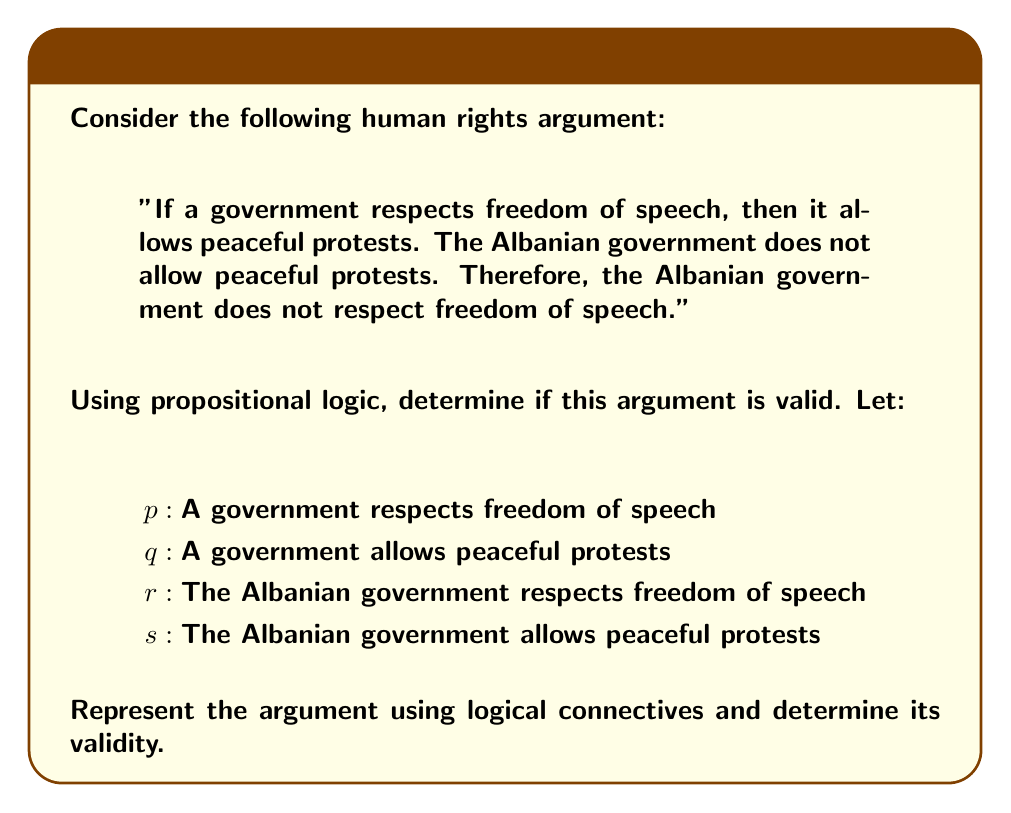What is the answer to this math problem? To analyze this argument using propositional logic, we'll follow these steps:

1) First, let's represent the given statements using logical connectives:

   Premise 1: $p \rightarrow q$ (If a government respects freedom of speech, then it allows peaceful protests)
   Premise 2: $\neg s$ (The Albanian government does not allow peaceful protests)
   Conclusion: $\neg r$ (The Albanian government does not respect freedom of speech)

2) The structure of this argument is:

   $$(p \rightarrow q) \land \neg s \therefore \neg r$$

3) To determine if this argument is valid, we need to check if the conclusion logically follows from the premises. In this case, we're using a form of argument known as modus tollens.

4) The general form of modus tollens is:

   $$p \rightarrow q$$
   $$\neg q$$
   $$\therefore \neg p$$

5) However, our argument doesn't exactly match this form. We have $\neg s$ instead of $\neg q$, and $\neg r$ instead of $\neg p$.

6) For this argument to be valid, we need to establish that $s$ is equivalent to $q$, and $r$ is equivalent to $p$, but for the specific case of the Albanian government.

7) If we accept these equivalences (which are implied by the context of the argument), then the argument does indeed follow the form of modus tollens and is therefore valid.

8) However, it's important to note that the validity of the argument doesn't guarantee the truth of its conclusion. The argument is valid in its logical structure, but its soundness depends on the truth of its premises.
Answer: The argument is valid if we accept the implied equivalences between the general statements ($p$ and $q$) and the specific statements about the Albanian government ($r$ and $s$). The argument follows the form of modus tollens: $(p \rightarrow q) \land \neg q \therefore \neg p$. 